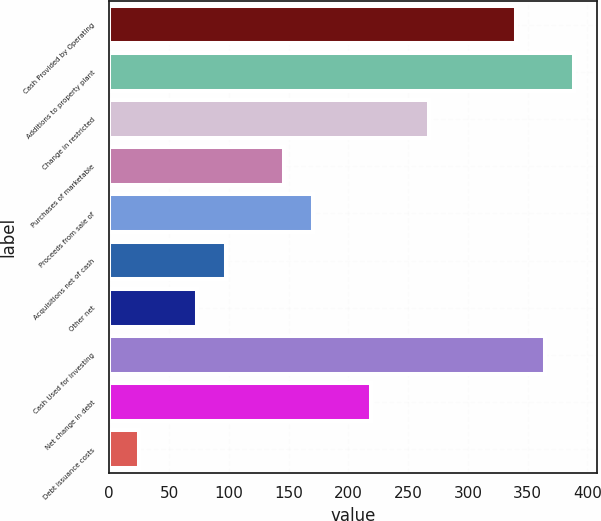Convert chart to OTSL. <chart><loc_0><loc_0><loc_500><loc_500><bar_chart><fcel>Cash Provided by Operating<fcel>Additions to property plant<fcel>Change in restricted<fcel>Purchases of marketable<fcel>Proceeds from sale of<fcel>Acquisitions net of cash<fcel>Other net<fcel>Cash Used for Investing<fcel>Net change in debt<fcel>Debt issuance costs<nl><fcel>340.1<fcel>388.64<fcel>267.29<fcel>145.94<fcel>170.21<fcel>97.4<fcel>73.13<fcel>364.37<fcel>218.75<fcel>24.59<nl></chart> 